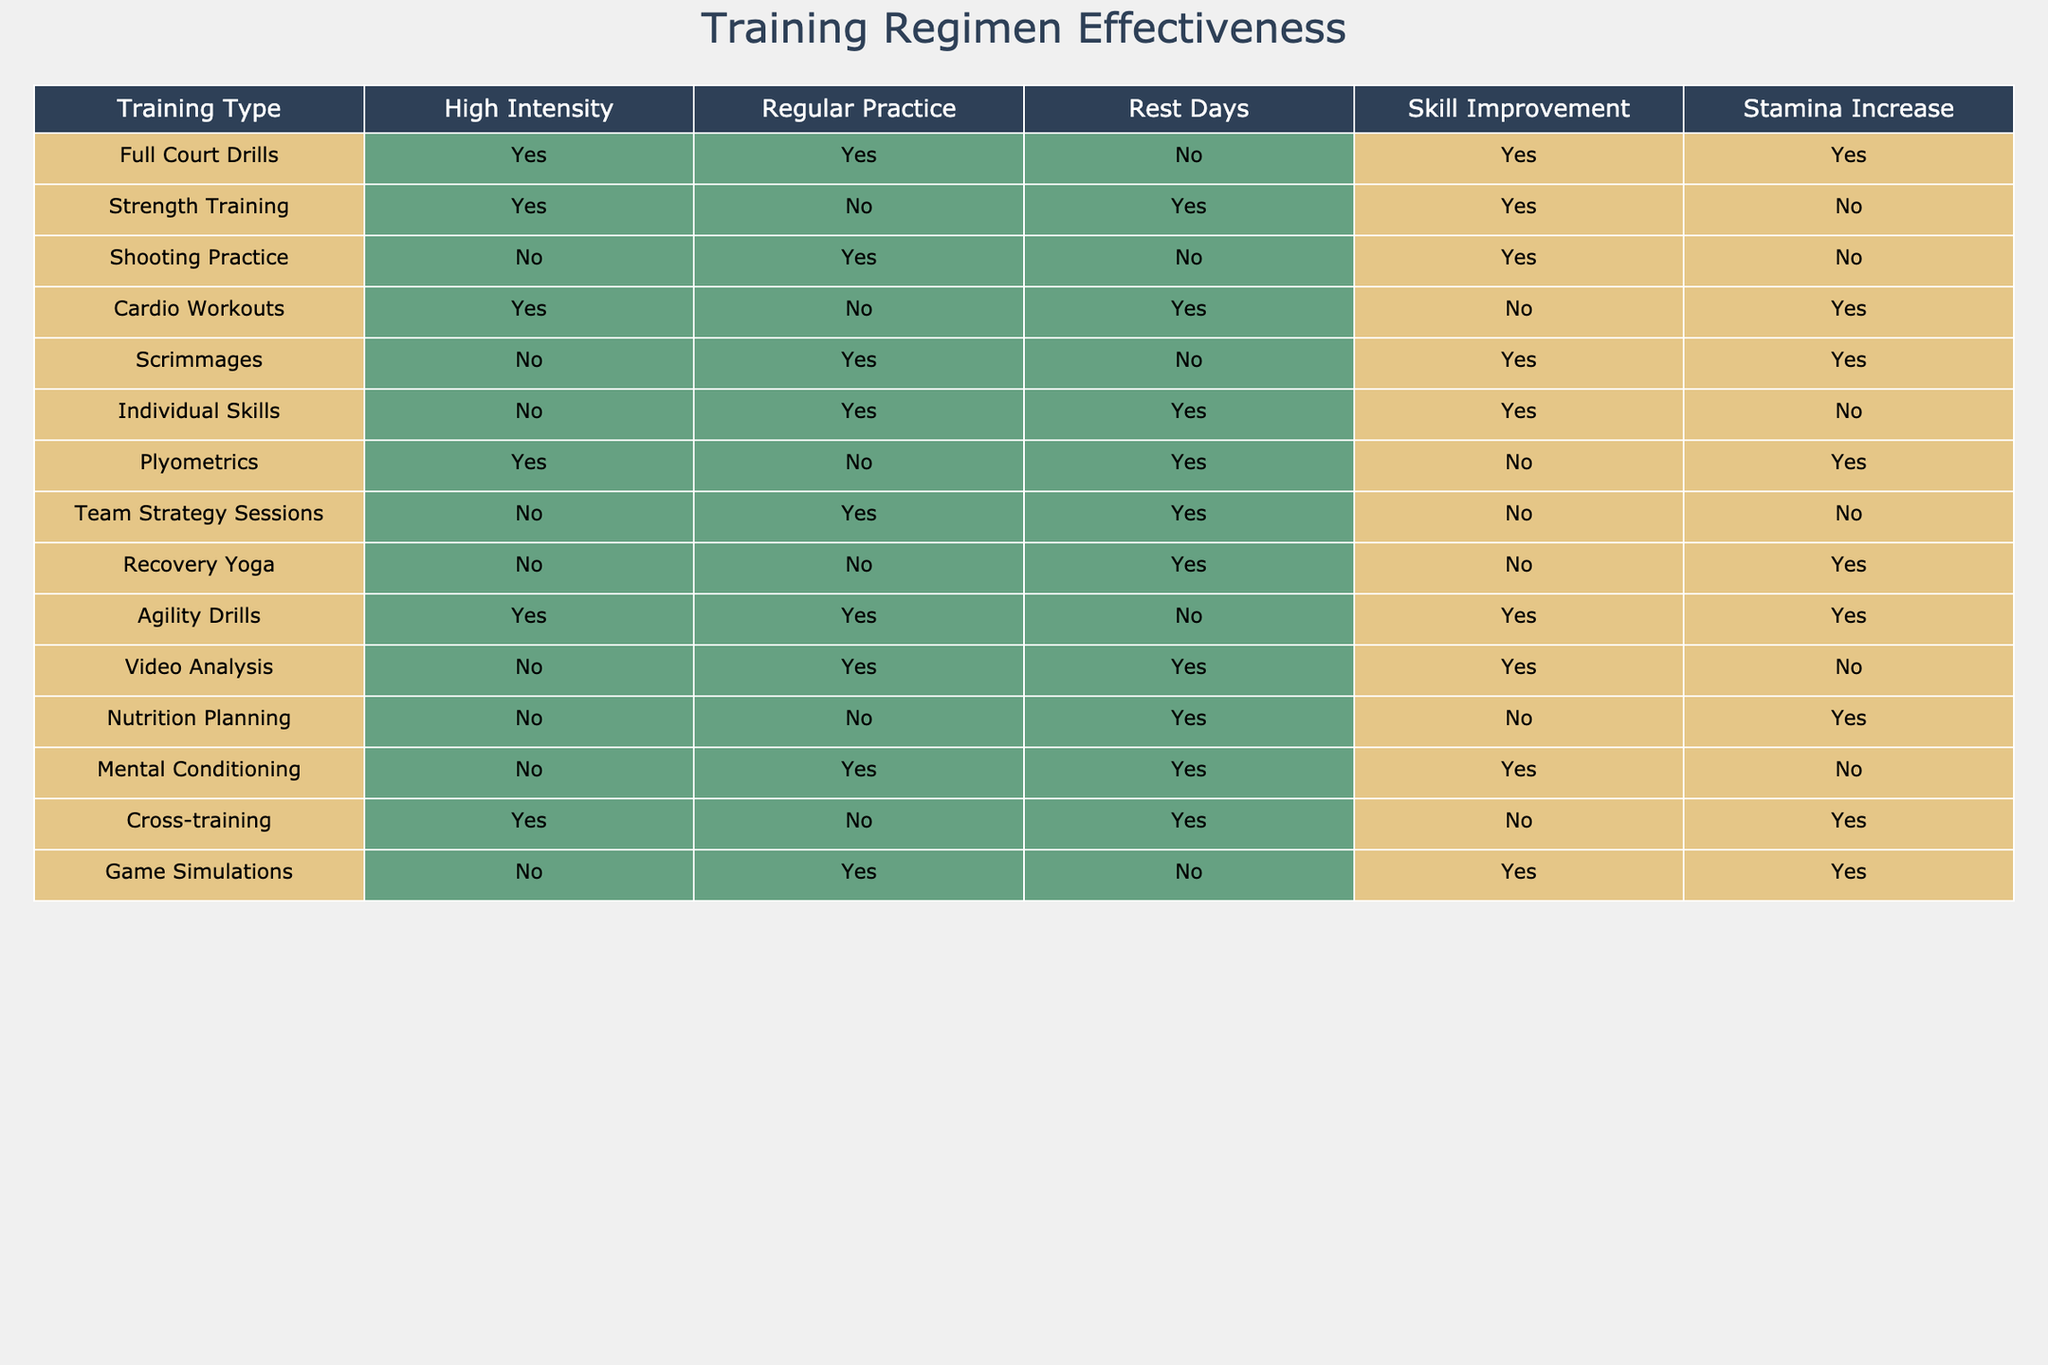What are the training types that improve both skill and stamina? To find the training types that improve both skill and stamina, look for rows where both "Skill Improvement" and "Stamina Increase" are marked as Yes. These are Full Court Drills and Agility Drills.
Answer: Full Court Drills, Agility Drills Which training type has high intensity but does not lead to skill improvement? Check the "High Intensity" column for TRUE and the "Skill Improvement" column for FALSE. The training type that meets these criteria is Plyometrics.
Answer: Plyometrics How many training types include regular practice? Count the number of rows where "Regular Practice" is marked as Yes. There are 7 training types that include "Regular Practice".
Answer: 7 Is there any training regimen that helps with stamina but not skill improvement? Identify the rows where "Stamina Increase" is Yes and "Skill Improvement" is No. The training types that fit this condition are Cardio Workouts and Recovery Yoga.
Answer: Yes, Cardio Workouts, Recovery Yoga What is the difference in the number of training types that involve rest days versus those that do not? Count the training types with "Rest Days" as Yes (5 types) and those with "Rest Days" as No (6 types). The difference is 6 - 5 = 1.
Answer: 1 List the training types that do NOT utilize high intensity or regular practice but still aid skill improvement. Identify rows where both "High Intensity" and "Regular Practice" are marked as No and "Skill Improvement" is Yes. Individual Skills, Video Analysis, and Mental Conditioning meet these criteria.
Answer: Individual Skills, Video Analysis, Mental Conditioning Does Strength Training increase stamina? Check the "Strength Training" row where "Stamina Increase" is marked. It is marked as No, so Strength Training does not increase stamina.
Answer: No How many training sessions listed help with skill improvement but have no high intensity? Look for "Skill Improvement" as Yes and "High Intensity" as No. The training types that fit are Shooting Practice, Scrimmages, Individual Skills, and Video Analysis. There are 4 such sessions.
Answer: 4 For training regimens that include high intensity, what percentage leads to skill improvement? Calculate the number of training types with "High Intensity" as Yes (6 types) and among those, check how many lead to "Skill Improvement" as Yes (4 types). The percentage is (4/6)*100 = approximately 67%.
Answer: 67% 